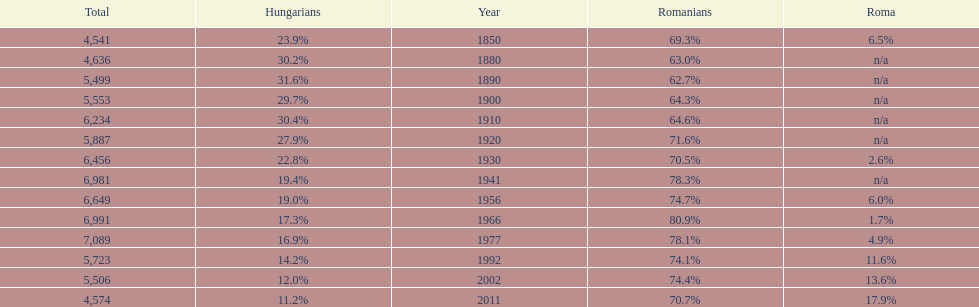What were the total number of times the romanians had a population percentage above 70%? 9. 